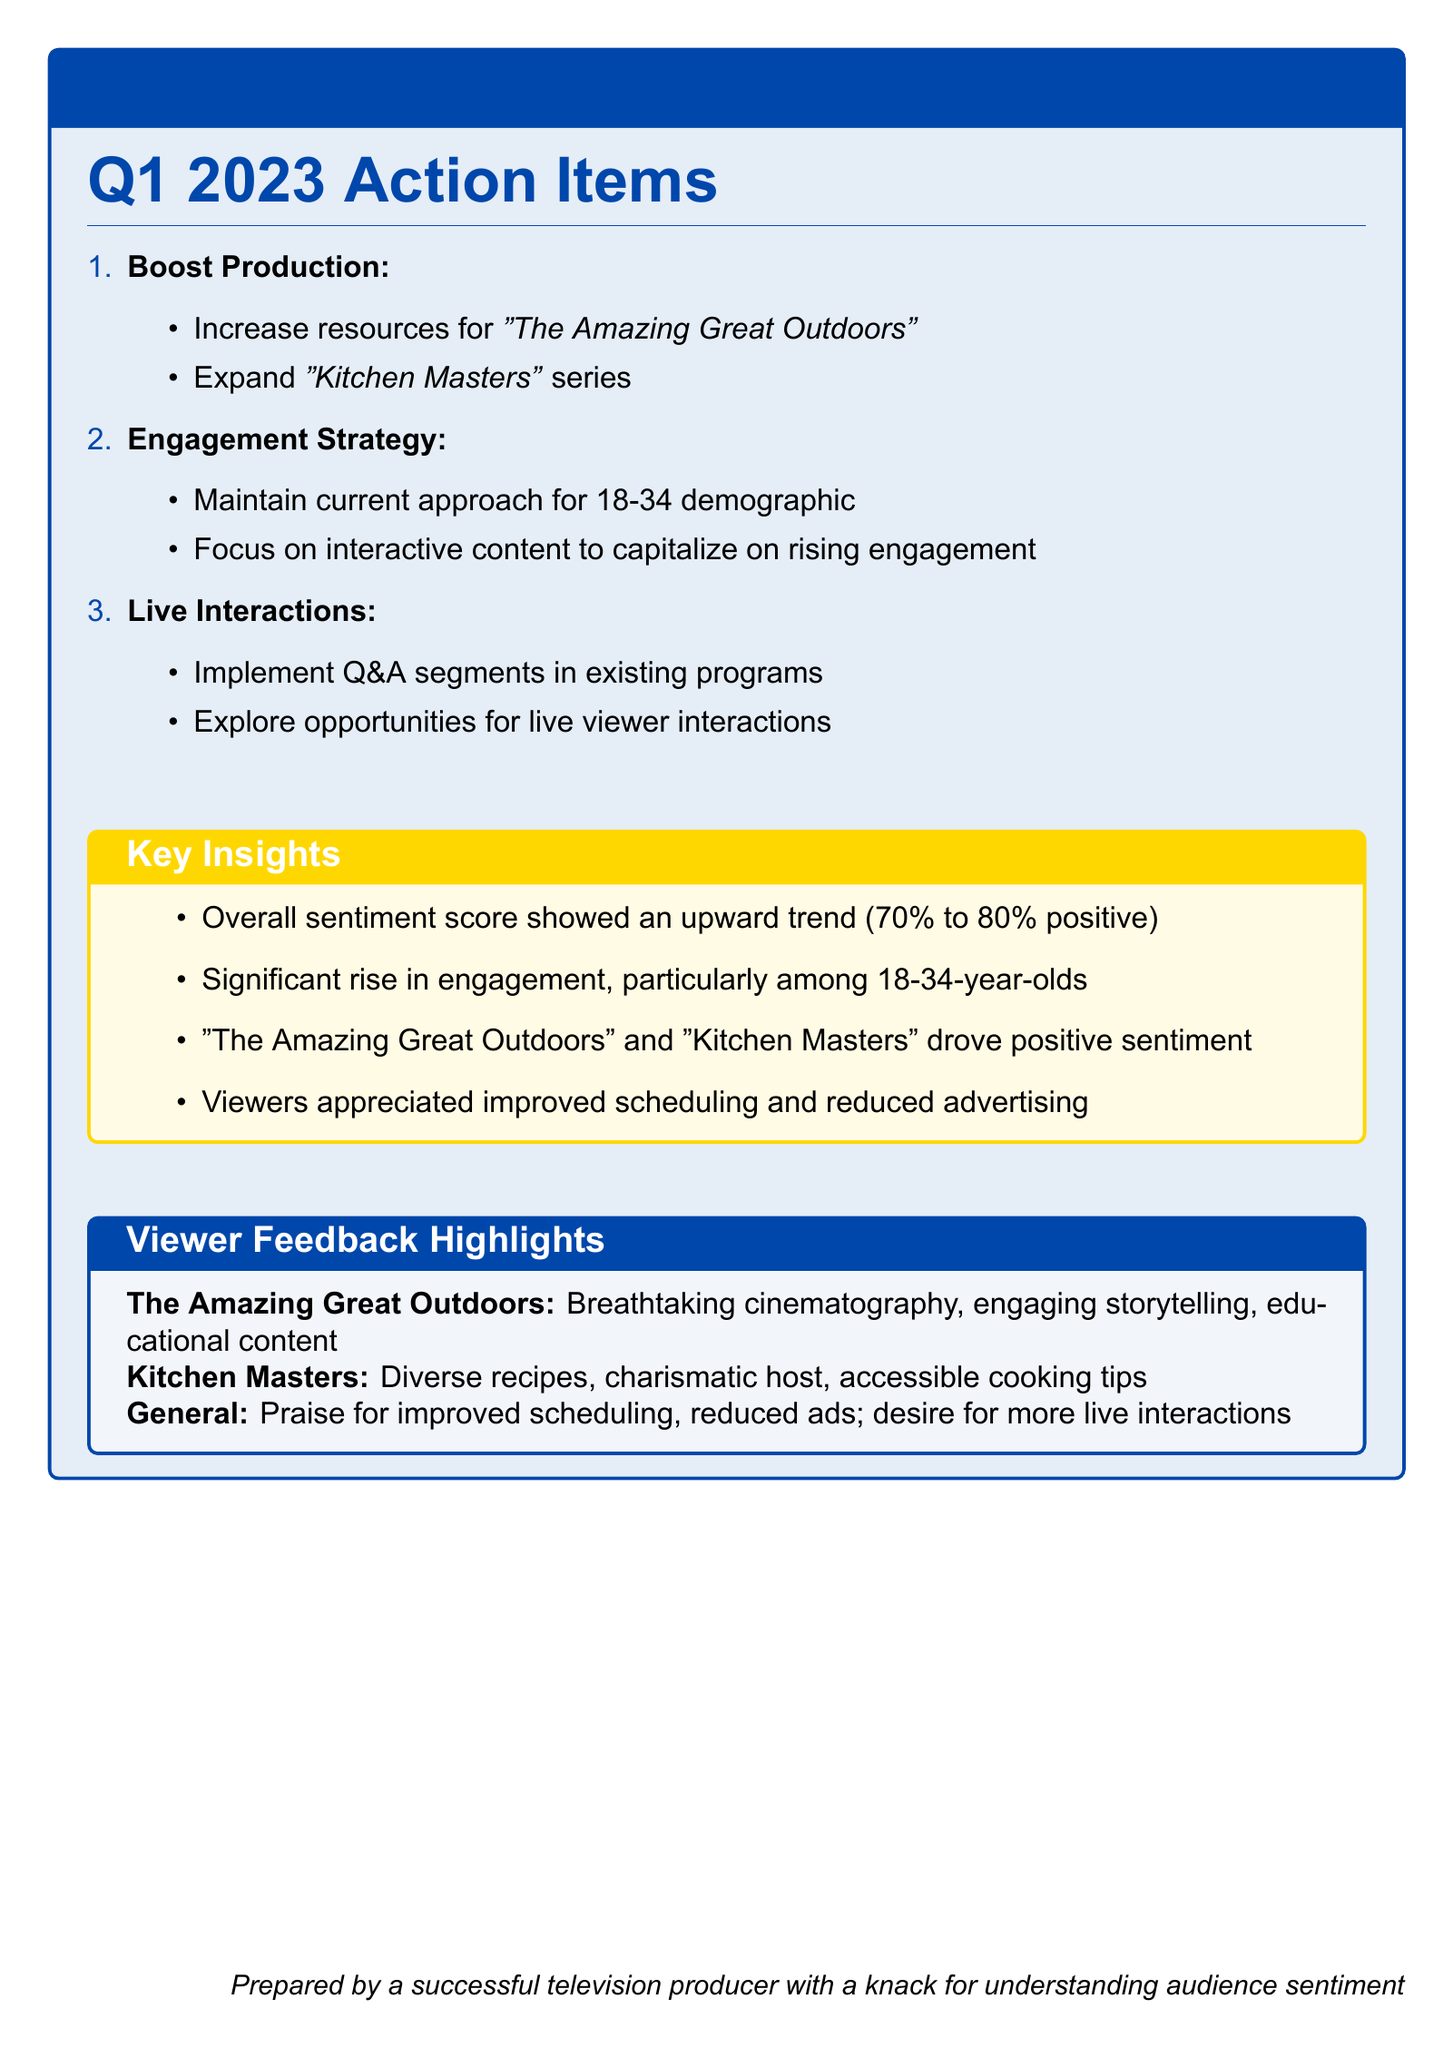what is the overall sentiment score trend from Q1 2023? The document indicates that the overall sentiment score showed an upward trend from 70% to 80% positive in Q1 2023.
Answer: 70% to 80% positive which two shows drove positive sentiment? The key insights highlight that "The Amazing Great Outdoors" and "Kitchen Masters" drove positive sentiment.
Answer: "The Amazing Great Outdoors" and "Kitchen Masters" what is one of the key insights regarding viewer engagement? Among the key insights, it is noted that there was a significant rise in engagement, particularly among the 18-34-year-olds demographic.
Answer: Significant rise in engagement what type of content should the engagement strategy focus on? The engagement strategy should focus on interactive content to capitalize on rising engagement.
Answer: Interactive content what improvements did viewers appreciate regarding the scheduling of shows? Viewers appreciated improved scheduling and reduced advertising according to the feedback highlights.
Answer: Improved scheduling and reduced ads what is suggested to implement in existing programs to enhance viewer interaction? The document suggests implementing Q&A segments in existing programs to enhance viewer interaction.
Answer: Q&A segments how has the audience sentiment changed compared to the previous quarter? The audience sentiment has shown an upward trend compared to the previous quarter, which is a positive change.
Answer: Upward trend what demographic should maintain the current engagement approach? The document mentions that the current approach should be maintained for the 18-34 demographic.
Answer: 18-34 demographic what feedback highlights were given for "Kitchen Masters"? Viewers provided feedback that included praise for diverse recipes, charismatic host, and accessible cooking tips for "Kitchen Masters".
Answer: Diverse recipes, charismatic host, accessible cooking tips 